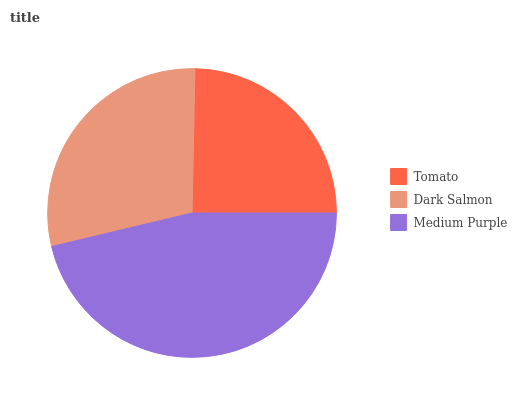Is Tomato the minimum?
Answer yes or no. Yes. Is Medium Purple the maximum?
Answer yes or no. Yes. Is Dark Salmon the minimum?
Answer yes or no. No. Is Dark Salmon the maximum?
Answer yes or no. No. Is Dark Salmon greater than Tomato?
Answer yes or no. Yes. Is Tomato less than Dark Salmon?
Answer yes or no. Yes. Is Tomato greater than Dark Salmon?
Answer yes or no. No. Is Dark Salmon less than Tomato?
Answer yes or no. No. Is Dark Salmon the high median?
Answer yes or no. Yes. Is Dark Salmon the low median?
Answer yes or no. Yes. Is Medium Purple the high median?
Answer yes or no. No. Is Medium Purple the low median?
Answer yes or no. No. 